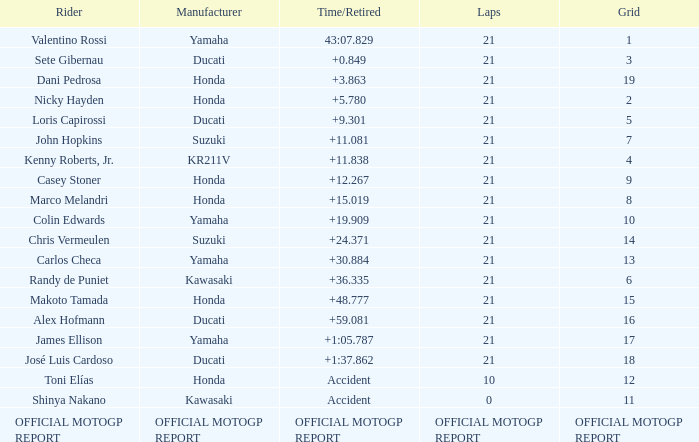WWhich rder had a vehicle manufactured by kr211v? Kenny Roberts, Jr. 